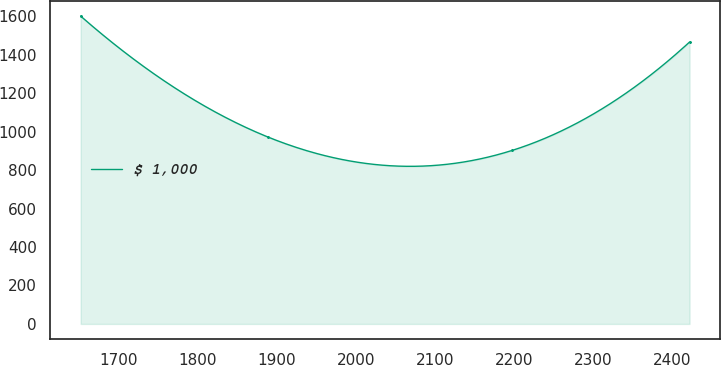<chart> <loc_0><loc_0><loc_500><loc_500><line_chart><ecel><fcel>$ 1,000<nl><fcel>1651.76<fcel>1600.99<nl><fcel>1888.24<fcel>972.71<nl><fcel>2197.89<fcel>902.9<nl><fcel>2421.89<fcel>1466.15<nl></chart> 